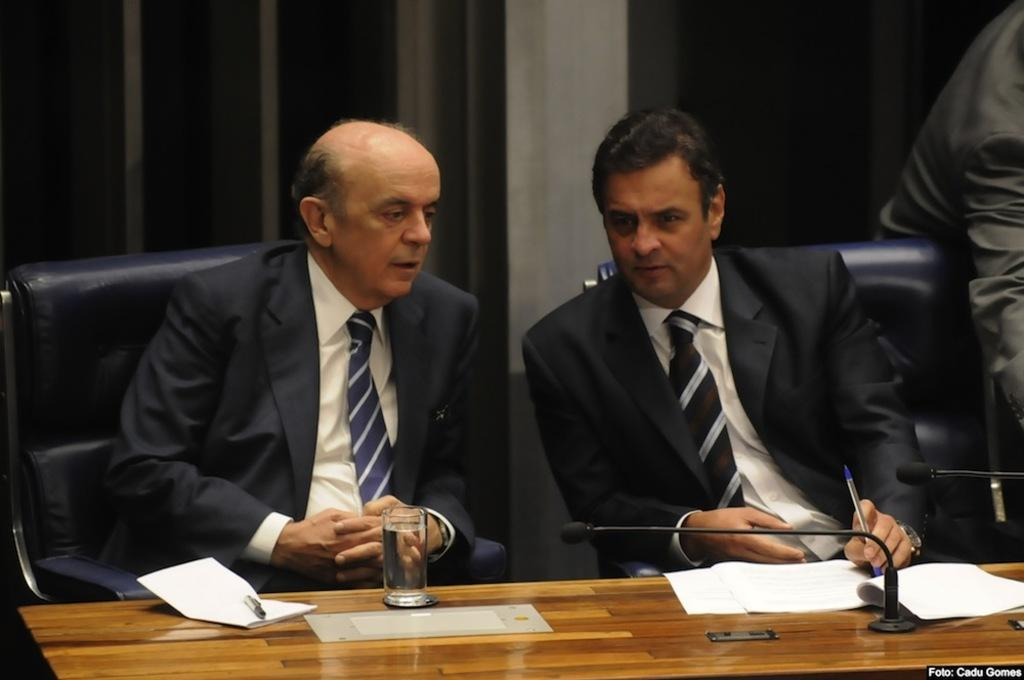How many people are in the image? There are two men in the image. What are the men doing in the image? The men are sitting on chairs and talking. What can be seen on the table in the image? There is a glass on the table. Where is the microphone located in the image? The microphone is on the right side of the image. What type of joke can be heard coming from the zoo in the image? There is no zoo present in the image, and therefore no jokes can be heard coming from it. Is there a cap visible on the head of either man in the image? There is no mention of a cap in the provided facts, so it cannot be determined if either man is wearing one. 